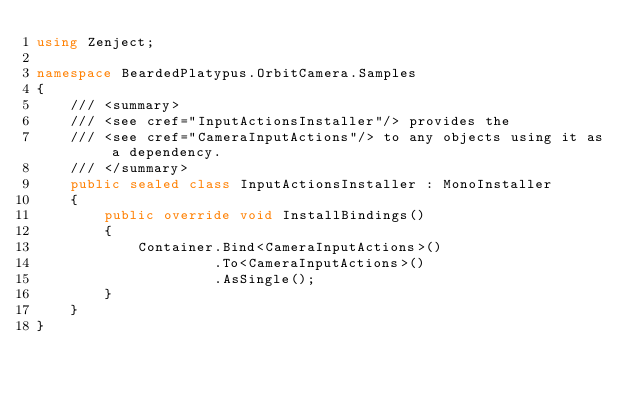<code> <loc_0><loc_0><loc_500><loc_500><_C#_>using Zenject;

namespace BeardedPlatypus.OrbitCamera.Samples
{
    /// <summary>
    /// <see cref="InputActionsInstaller"/> provides the
    /// <see cref="CameraInputActions"/> to any objects using it as a dependency.
    /// </summary>
    public sealed class InputActionsInstaller : MonoInstaller
    {
        public override void InstallBindings()
        {
            Container.Bind<CameraInputActions>()
                     .To<CameraInputActions>()
                     .AsSingle();
        }
    }
}</code> 